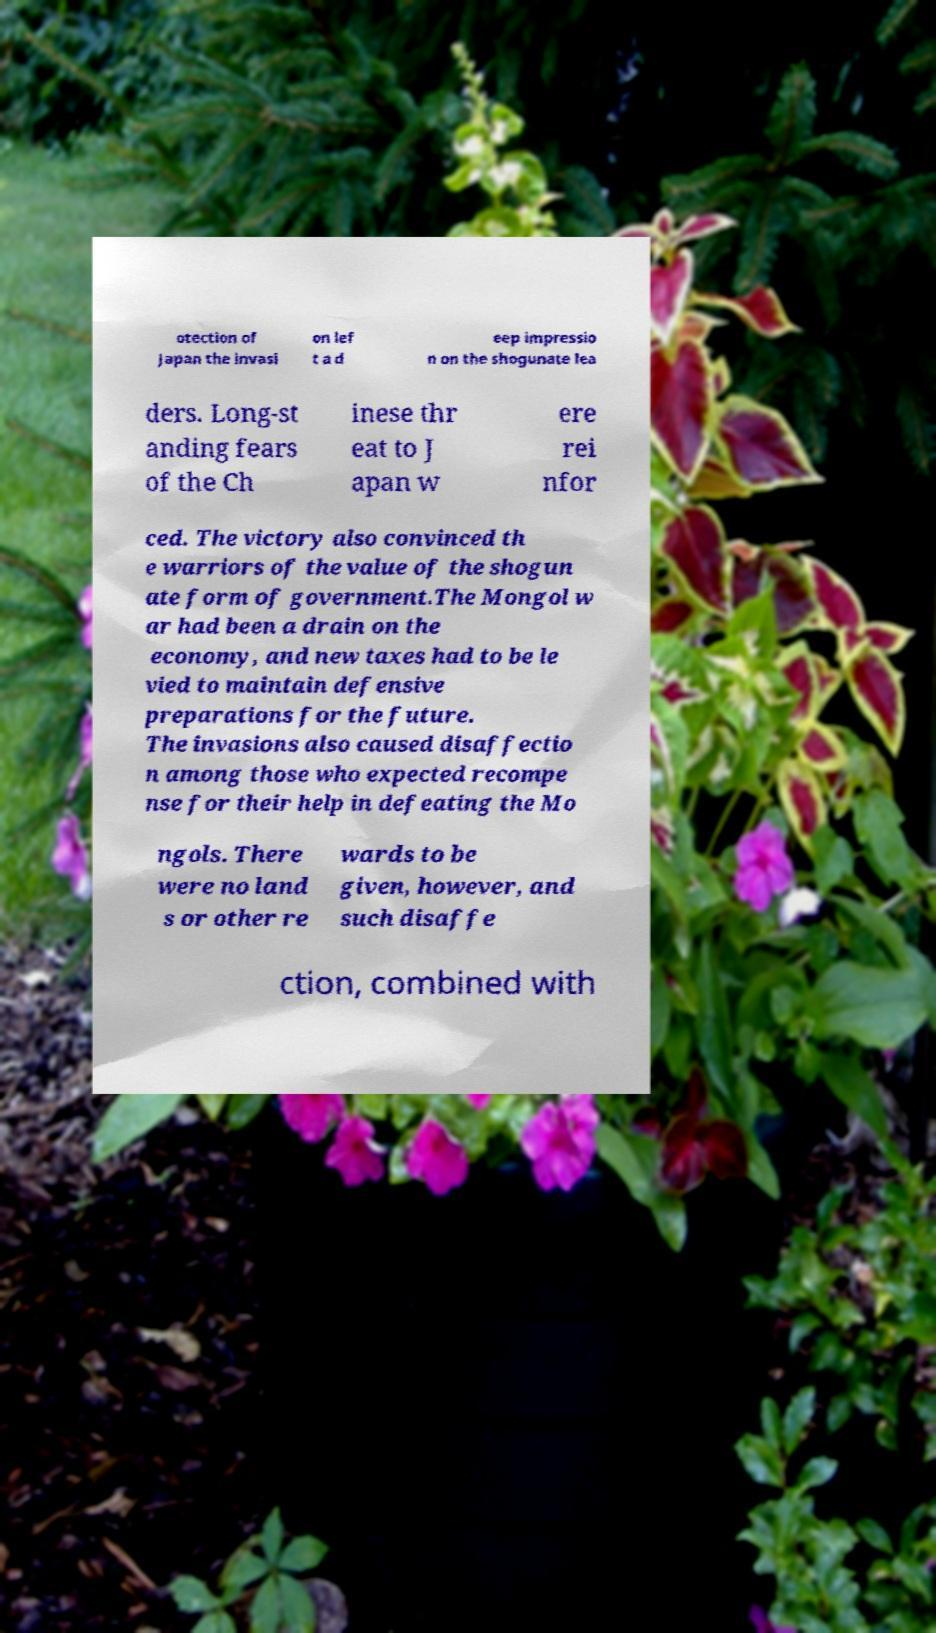For documentation purposes, I need the text within this image transcribed. Could you provide that? otection of Japan the invasi on lef t a d eep impressio n on the shogunate lea ders. Long-st anding fears of the Ch inese thr eat to J apan w ere rei nfor ced. The victory also convinced th e warriors of the value of the shogun ate form of government.The Mongol w ar had been a drain on the economy, and new taxes had to be le vied to maintain defensive preparations for the future. The invasions also caused disaffectio n among those who expected recompe nse for their help in defeating the Mo ngols. There were no land s or other re wards to be given, however, and such disaffe ction, combined with 